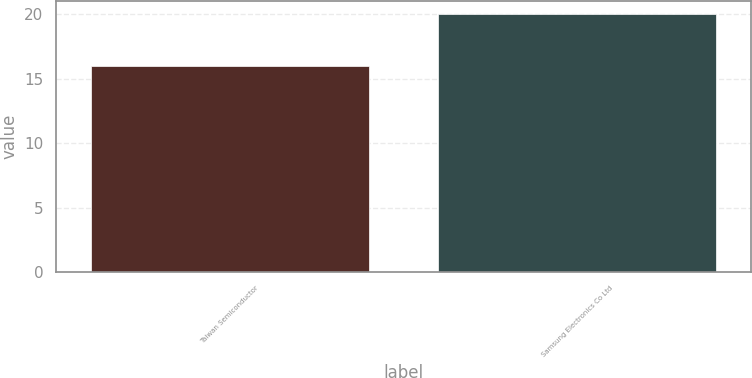Convert chart. <chart><loc_0><loc_0><loc_500><loc_500><bar_chart><fcel>Taiwan Semiconductor<fcel>Samsung Electronics Co Ltd<nl><fcel>16<fcel>20<nl></chart> 